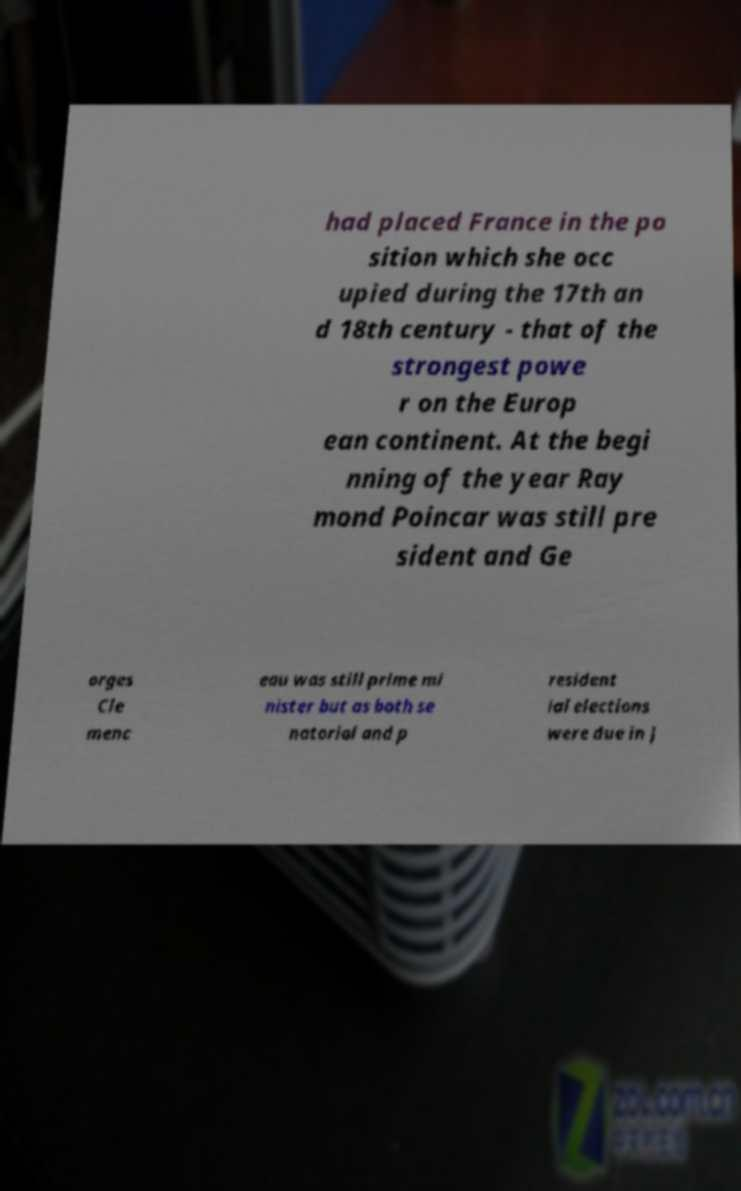Can you read and provide the text displayed in the image?This photo seems to have some interesting text. Can you extract and type it out for me? had placed France in the po sition which she occ upied during the 17th an d 18th century - that of the strongest powe r on the Europ ean continent. At the begi nning of the year Ray mond Poincar was still pre sident and Ge orges Cle menc eau was still prime mi nister but as both se natorial and p resident ial elections were due in J 